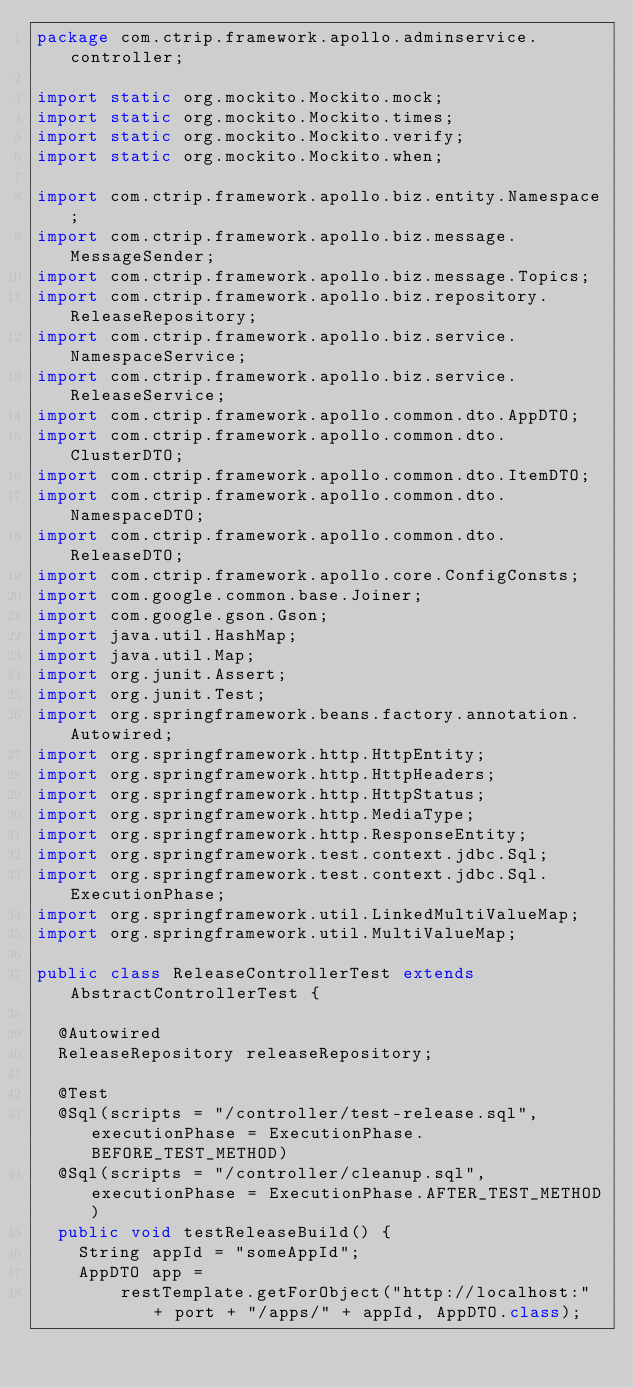Convert code to text. <code><loc_0><loc_0><loc_500><loc_500><_Java_>package com.ctrip.framework.apollo.adminservice.controller;

import static org.mockito.Mockito.mock;
import static org.mockito.Mockito.times;
import static org.mockito.Mockito.verify;
import static org.mockito.Mockito.when;

import com.ctrip.framework.apollo.biz.entity.Namespace;
import com.ctrip.framework.apollo.biz.message.MessageSender;
import com.ctrip.framework.apollo.biz.message.Topics;
import com.ctrip.framework.apollo.biz.repository.ReleaseRepository;
import com.ctrip.framework.apollo.biz.service.NamespaceService;
import com.ctrip.framework.apollo.biz.service.ReleaseService;
import com.ctrip.framework.apollo.common.dto.AppDTO;
import com.ctrip.framework.apollo.common.dto.ClusterDTO;
import com.ctrip.framework.apollo.common.dto.ItemDTO;
import com.ctrip.framework.apollo.common.dto.NamespaceDTO;
import com.ctrip.framework.apollo.common.dto.ReleaseDTO;
import com.ctrip.framework.apollo.core.ConfigConsts;
import com.google.common.base.Joiner;
import com.google.gson.Gson;
import java.util.HashMap;
import java.util.Map;
import org.junit.Assert;
import org.junit.Test;
import org.springframework.beans.factory.annotation.Autowired;
import org.springframework.http.HttpEntity;
import org.springframework.http.HttpHeaders;
import org.springframework.http.HttpStatus;
import org.springframework.http.MediaType;
import org.springframework.http.ResponseEntity;
import org.springframework.test.context.jdbc.Sql;
import org.springframework.test.context.jdbc.Sql.ExecutionPhase;
import org.springframework.util.LinkedMultiValueMap;
import org.springframework.util.MultiValueMap;

public class ReleaseControllerTest extends AbstractControllerTest {

  @Autowired
  ReleaseRepository releaseRepository;

  @Test
  @Sql(scripts = "/controller/test-release.sql", executionPhase = ExecutionPhase.BEFORE_TEST_METHOD)
  @Sql(scripts = "/controller/cleanup.sql", executionPhase = ExecutionPhase.AFTER_TEST_METHOD)
  public void testReleaseBuild() {
    String appId = "someAppId";
    AppDTO app =
        restTemplate.getForObject("http://localhost:" + port + "/apps/" + appId, AppDTO.class);
</code> 